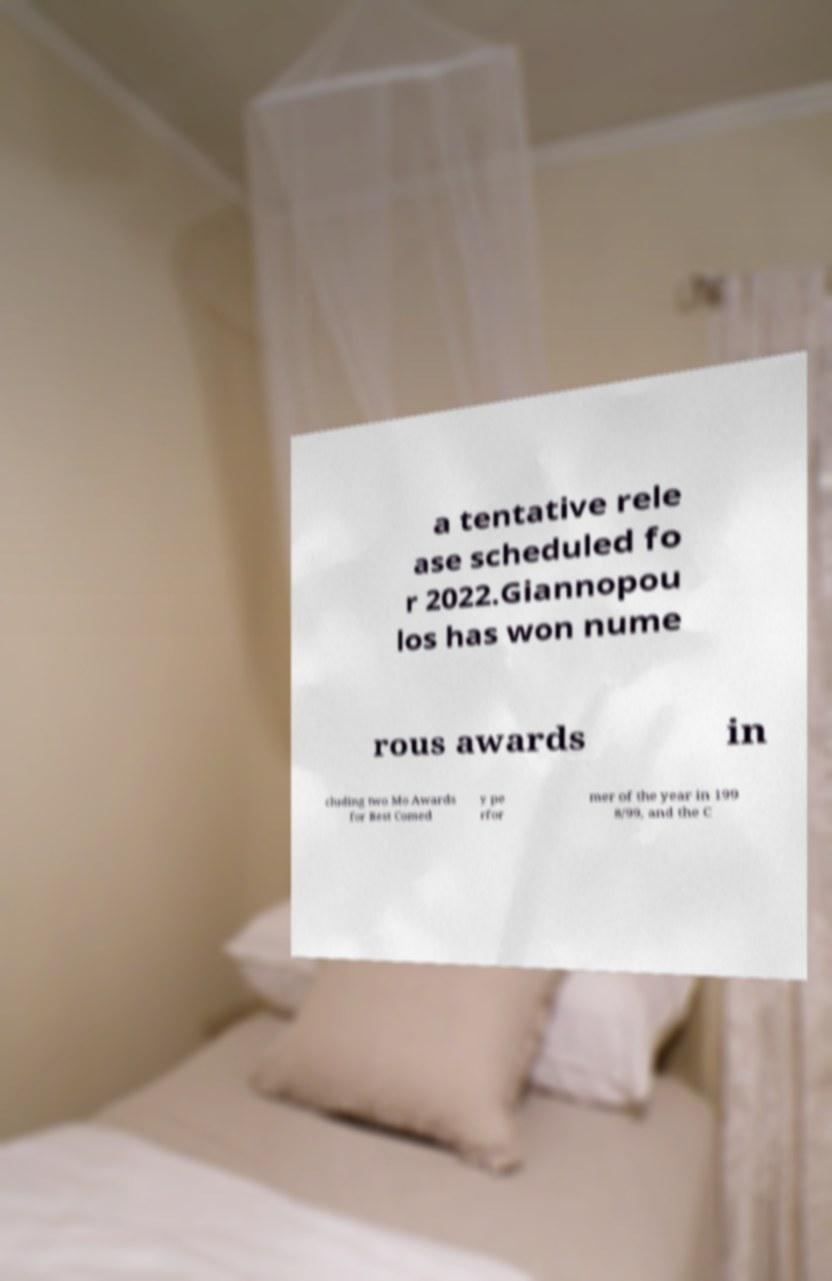For documentation purposes, I need the text within this image transcribed. Could you provide that? a tentative rele ase scheduled fo r 2022.Giannopou los has won nume rous awards in cluding two Mo Awards for Best Comed y pe rfor mer of the year in 199 8/99, and the C 